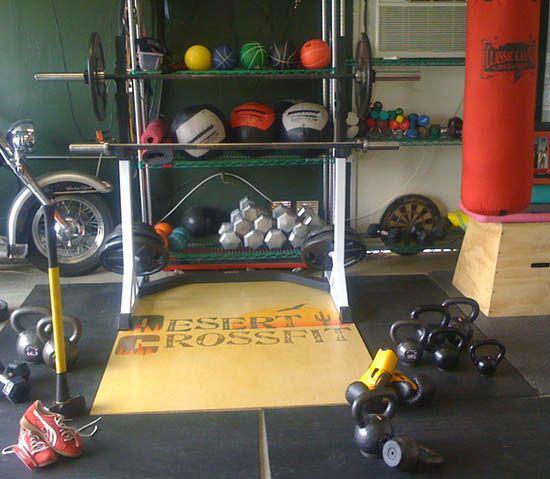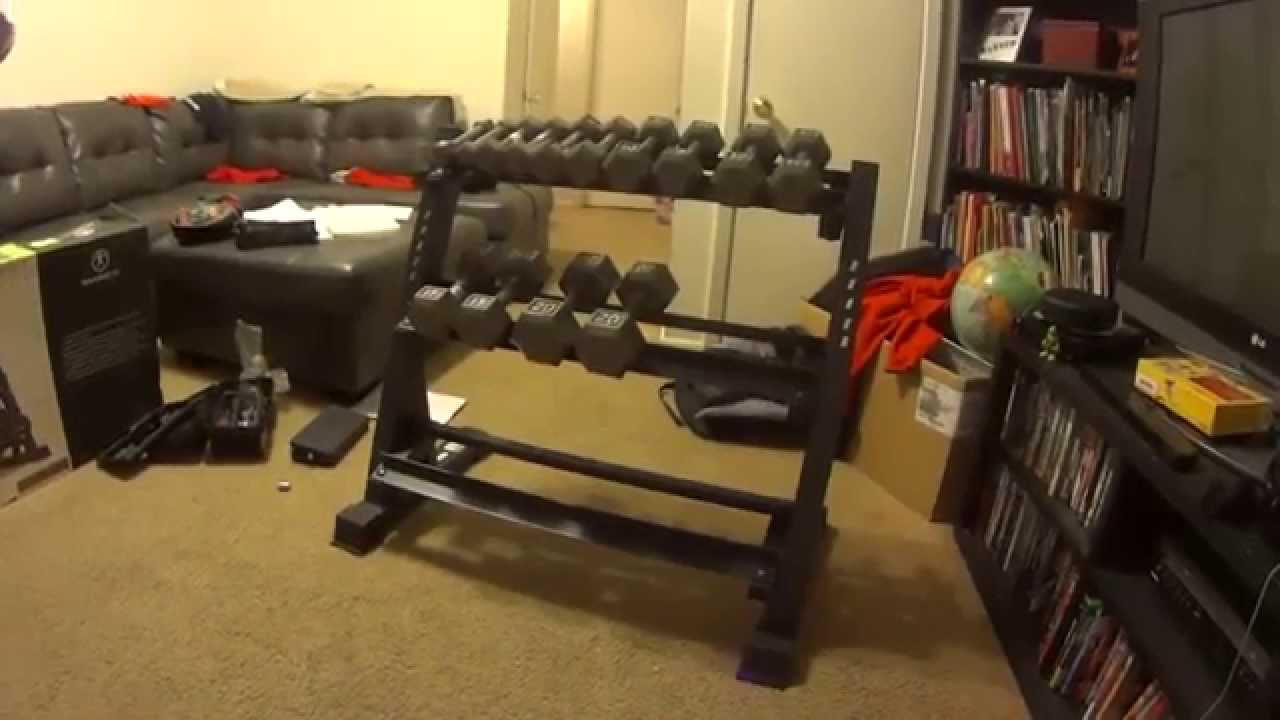The first image is the image on the left, the second image is the image on the right. For the images displayed, is the sentence "there is a weight racj with two rows of weights in the left image" factually correct? Answer yes or no. No. 